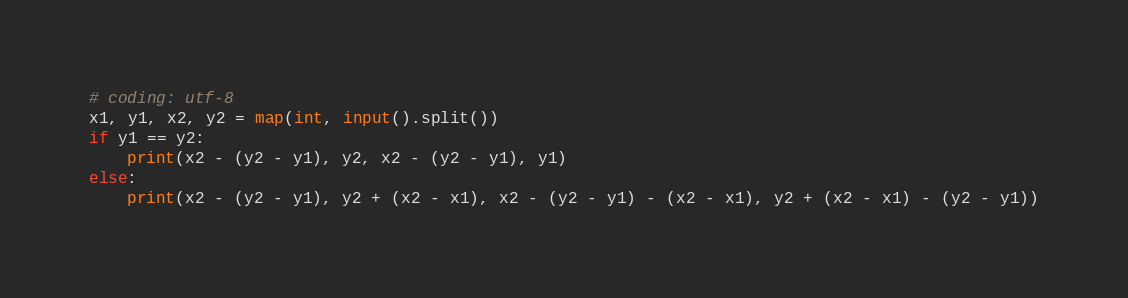<code> <loc_0><loc_0><loc_500><loc_500><_Python_># coding: utf-8
x1, y1, x2, y2 = map(int, input().split())
if y1 == y2:
    print(x2 - (y2 - y1), y2, x2 - (y2 - y1), y1)
else:
    print(x2 - (y2 - y1), y2 + (x2 - x1), x2 - (y2 - y1) - (x2 - x1), y2 + (x2 - x1) - (y2 - y1))</code> 